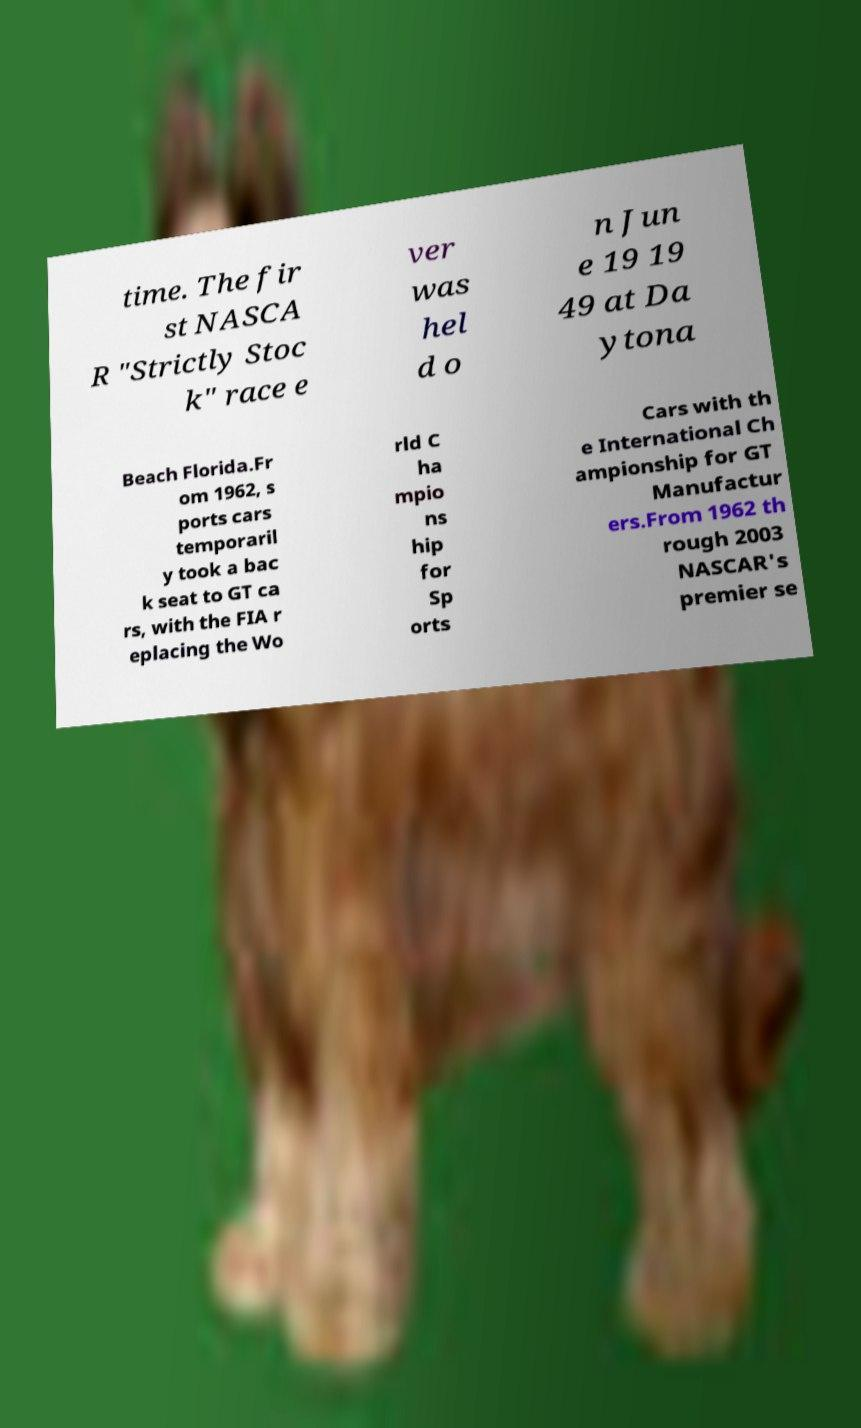Could you extract and type out the text from this image? time. The fir st NASCA R "Strictly Stoc k" race e ver was hel d o n Jun e 19 19 49 at Da ytona Beach Florida.Fr om 1962, s ports cars temporaril y took a bac k seat to GT ca rs, with the FIA r eplacing the Wo rld C ha mpio ns hip for Sp orts Cars with th e International Ch ampionship for GT Manufactur ers.From 1962 th rough 2003 NASCAR's premier se 